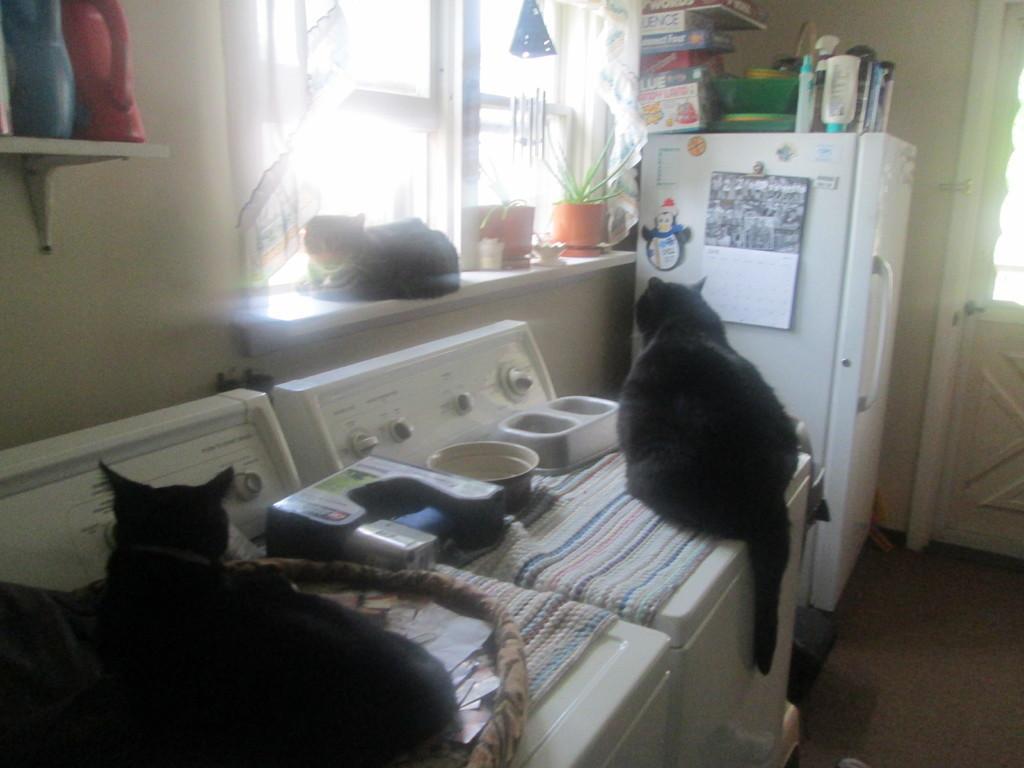Describe this image in one or two sentences. In this picture there are cats on the stove at the bottom side of the image and there is a refrigerator on the right side of the image, on which there are boxes, there is another cat in the center of the image, there is a cat at the top side of the image. 